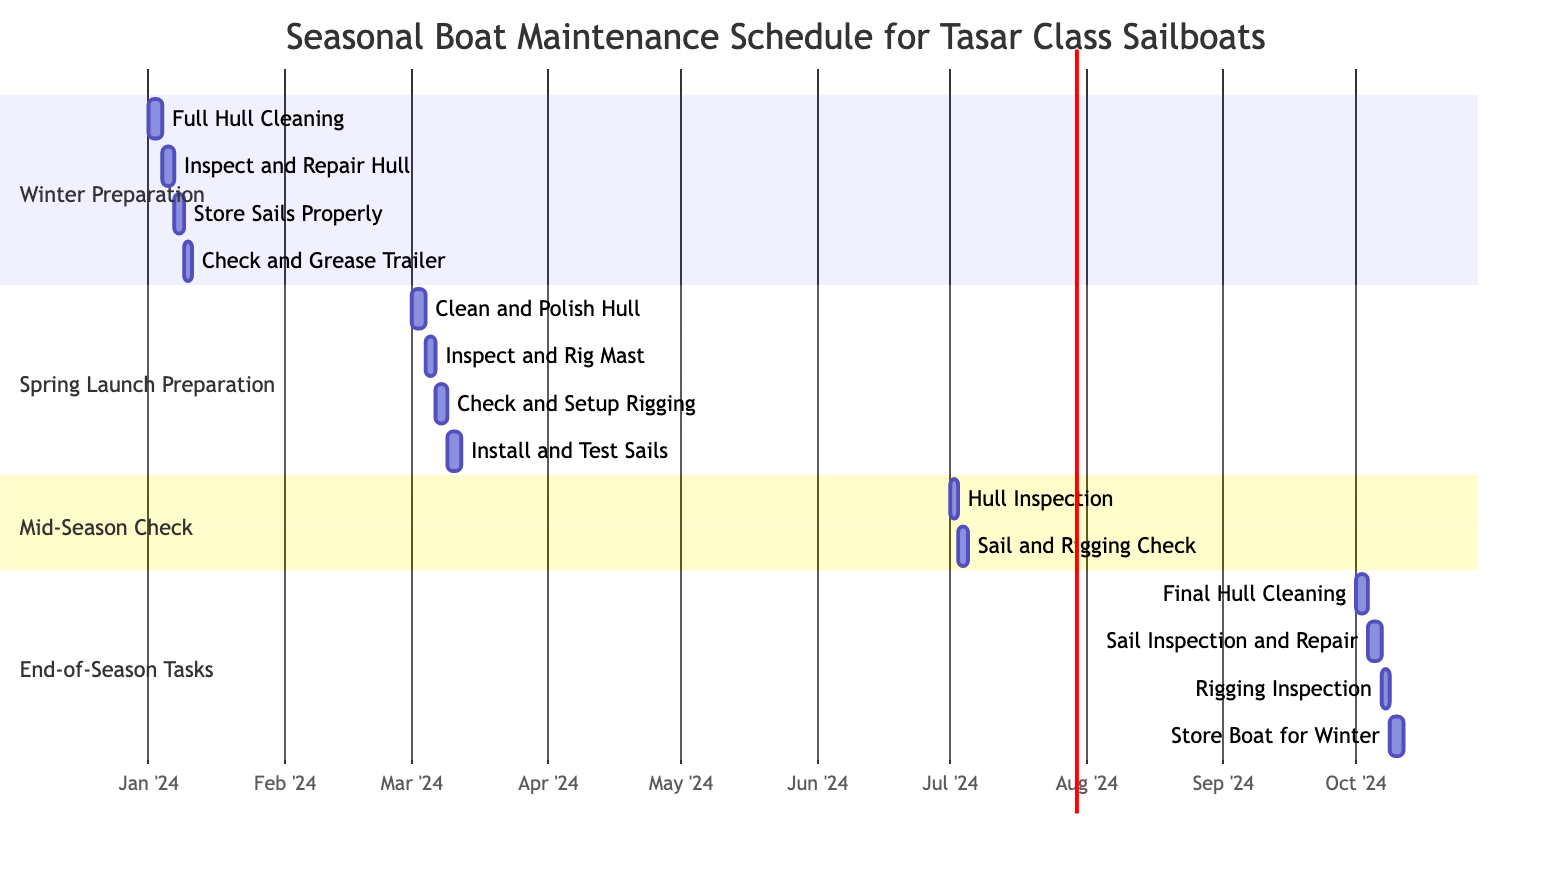What is the duration of the Winter Preparation phase? The Winter Preparation phase starts on January 1, 2024, and ends on January 15, 2024. The duration can be calculated as the difference between the end date and start date, which is 15 days.
Answer: 15 days Which task is scheduled right after "Inspect and Rig Mast"? The "Inspect and Rig Mast" task starts on March 4, 2024, and ends on March 5, 2024. The next task, "Check and Setup Rigging," begins on March 6, 2024, immediately following it.
Answer: Check and Setup Rigging How many total subtasks are there in the End-of-Season Tasks? The End-of-Season Tasks contain 4 subtasks: "Final Hull Cleaning," "Sail Inspection and Repair," "Rigging Inspection," and "Store Boat for Winter." Therefore, the total number of subtasks in this section is 4.
Answer: 4 Which task overlaps with the "Sail and Rigging Check"? The "Sail and Rigging Check" task starts on July 3, 2024, and ends on July 4, 2024. The "Hull Inspection" task overlaps on July 1-2, but does not overlap with "Sail and Rigging Check." The closest task, "Sail and Rigging Check," does not share days with any other main tasks.
Answer: None What is the earliest task in the Seasonal Boat Maintenance Schedule? The earliest task listed in the schedule is "Full Hull Cleaning," which starts on January 1, 2024. No other task begins before this date.
Answer: Full Hull Cleaning 